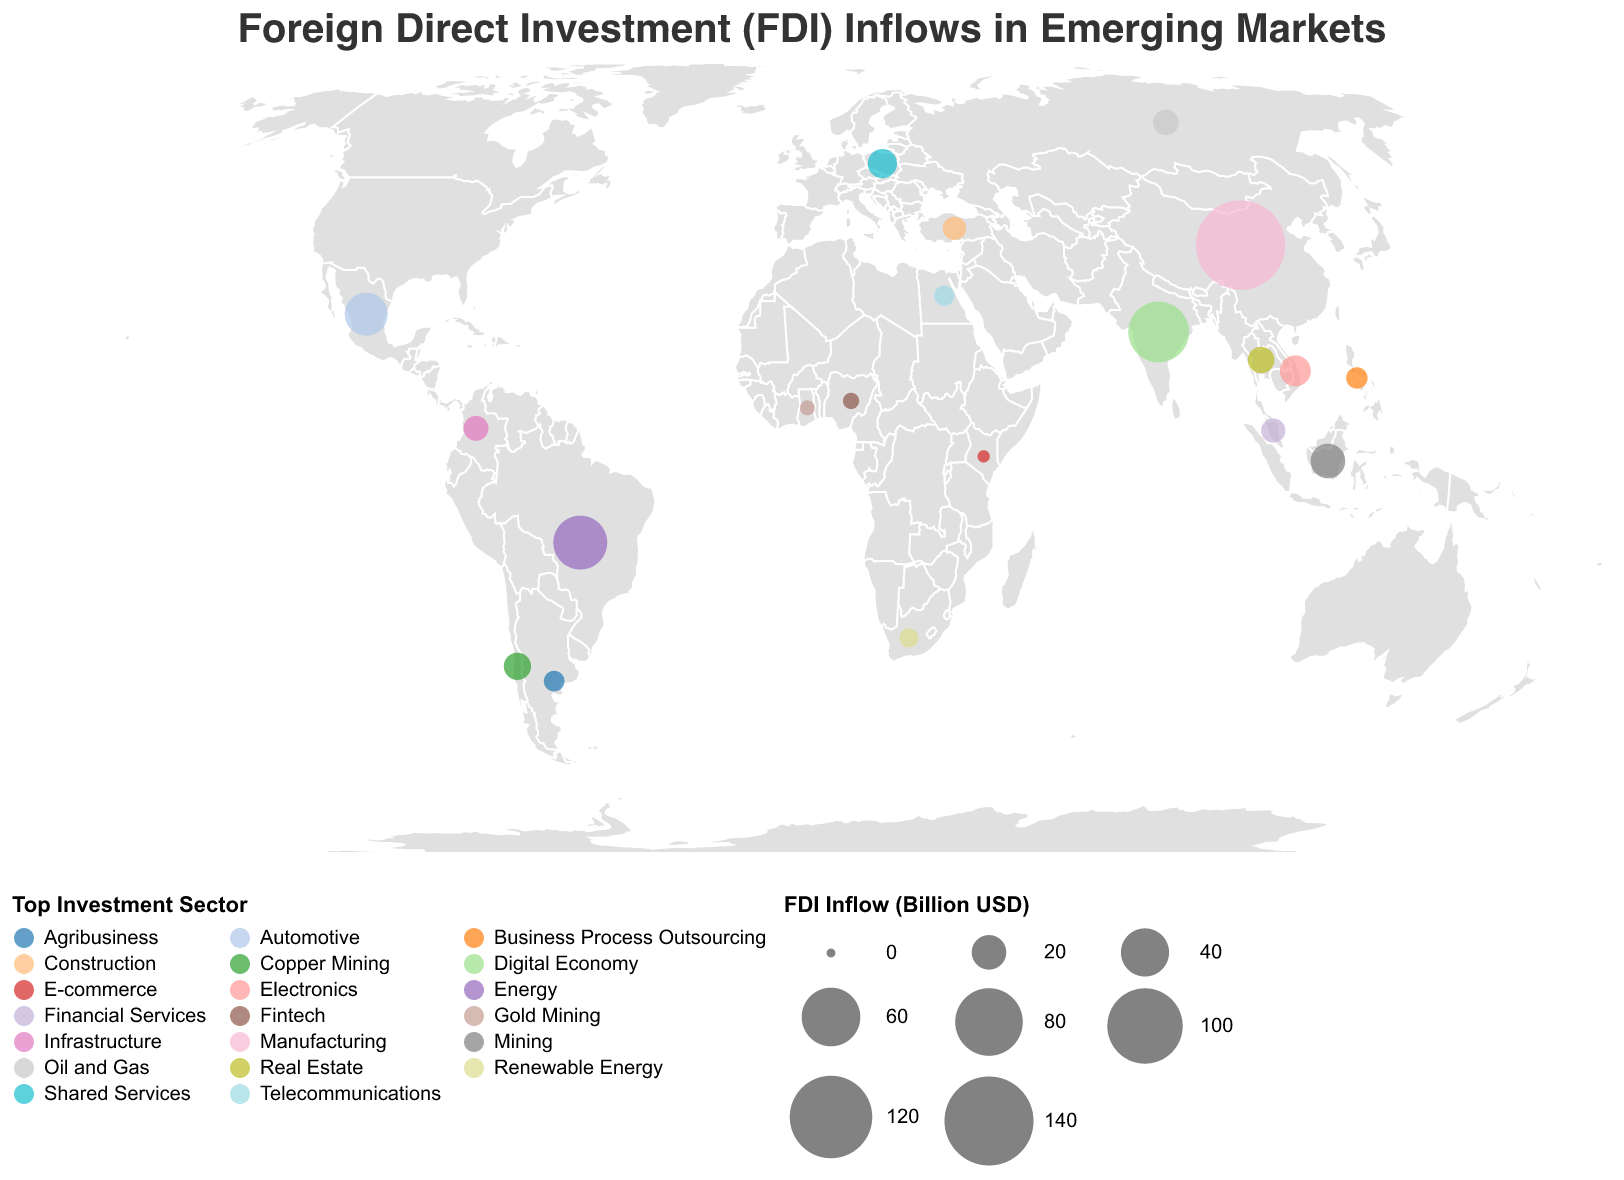What is the country with the highest FDI inflow? The country with the largest circle indicating the Foreign Direct Investment (FDI) Inflow (Billion USD) will have the highest inflow. According to the plot, the largest circle is for China.
Answer: China Which sector attracts the most FDI in Nigeria? By identifying the country of Nigeria on the map, and observing the color-coded legend for the sector, the top sector for Nigeria is Fintech.
Answer: Fintech Compare the FDI inflows of Mexico and Vietnam. Which country has a higher FDI inflow? Look for Mexico and Vietnam on the geographic plot, and compare the size of the circles. The circle for Mexico is larger, meaning it has a higher FDI inflow than Vietnam.
Answer: Mexico Which countries have an FDI inflow between 10 and 20 billion USD? Locate the circles whose sizes correspond to FDI inflows between 10 and 20 billion USD. The countries falling into this range on the map are Vietnam, Thailand, Poland, Russia, and Chile.
Answer: Vietnam, Thailand, Poland, Russia, Chile What is the average FDI inflow for the countries listed? To find the average, sum the FDI inflows for all countries and divide by the number of countries. (141.2 + 64.4 + 50.4 + 31.6 + 20.1 + 15.8 + 11.2 + 9.1 + 6.8 + 5.1 + 8.4 + 10.3 + 13.9 + 11.9 + 9.7 + 6.2 + 5.9 + 3.3 + 1.3 + 2.6) / 20 = 22.47 billion USD
Answer: 22.47 billion USD Which country is the prime destination for investment in the telecommunications sector? Identify the country on the plot where the top sector is telecommunications. This can be checked through the color legend. Egypt is the country with telecommunications as the leading sector.
Answer: Egypt How many countries attract significant FDI in the mining sector (including both Mining and Copper Mining)? Identify the countries with Mining and Copper Mining from the plot based on the top sector's color. These countries are Indonesia (Mining), Chile (Copper Mining), and Ghana (Gold Mining). There are 3 countries in total.
Answer: 3 Which top investment sector is most common among the listed countries? Count the unique sectors listed and note which occurs most frequently. 'Mining' and its sub-categories combined occur in 3 countries, which is the highest.
Answer: Mining (including sub-categories) Which country in Africa has the highest FDI inflow and what is its top sector? By examining the African countries on the map and comparing the circle sizes, South Africa has the highest FDI inflow. The top sector is Renewable Energy.
Answer: South Africa, Renewable Energy Which sectors are top investment destinations in South American countries (Brazil, Chile, Colombia, Argentina)? Check the plot for the sectors listed for Brazil, Chile, Colombia, Argentina. Brazil is Energy, Chile is Copper Mining, Colombia is Infrastructure, and Argentina is Agribusiness.
Answer: Energy, Copper Mining, Infrastructure, Agribusiness 